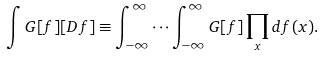Convert formula to latex. <formula><loc_0><loc_0><loc_500><loc_500>\int G [ f ] [ D f ] \equiv \int _ { - \infty } ^ { \infty } \cdots \int _ { - \infty } ^ { \infty } G [ f ] \prod _ { x } d f ( x ) .</formula> 